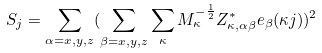Convert formula to latex. <formula><loc_0><loc_0><loc_500><loc_500>S _ { j } = \sum _ { \alpha = x , y , z } ( \sum _ { \beta = x , y , z } \sum _ { \kappa } M _ { \kappa } ^ { - \frac { 1 } { 2 } } Z ^ { * } _ { \kappa , \alpha \beta } e _ { \beta } ( \kappa j ) ) ^ { 2 }</formula> 